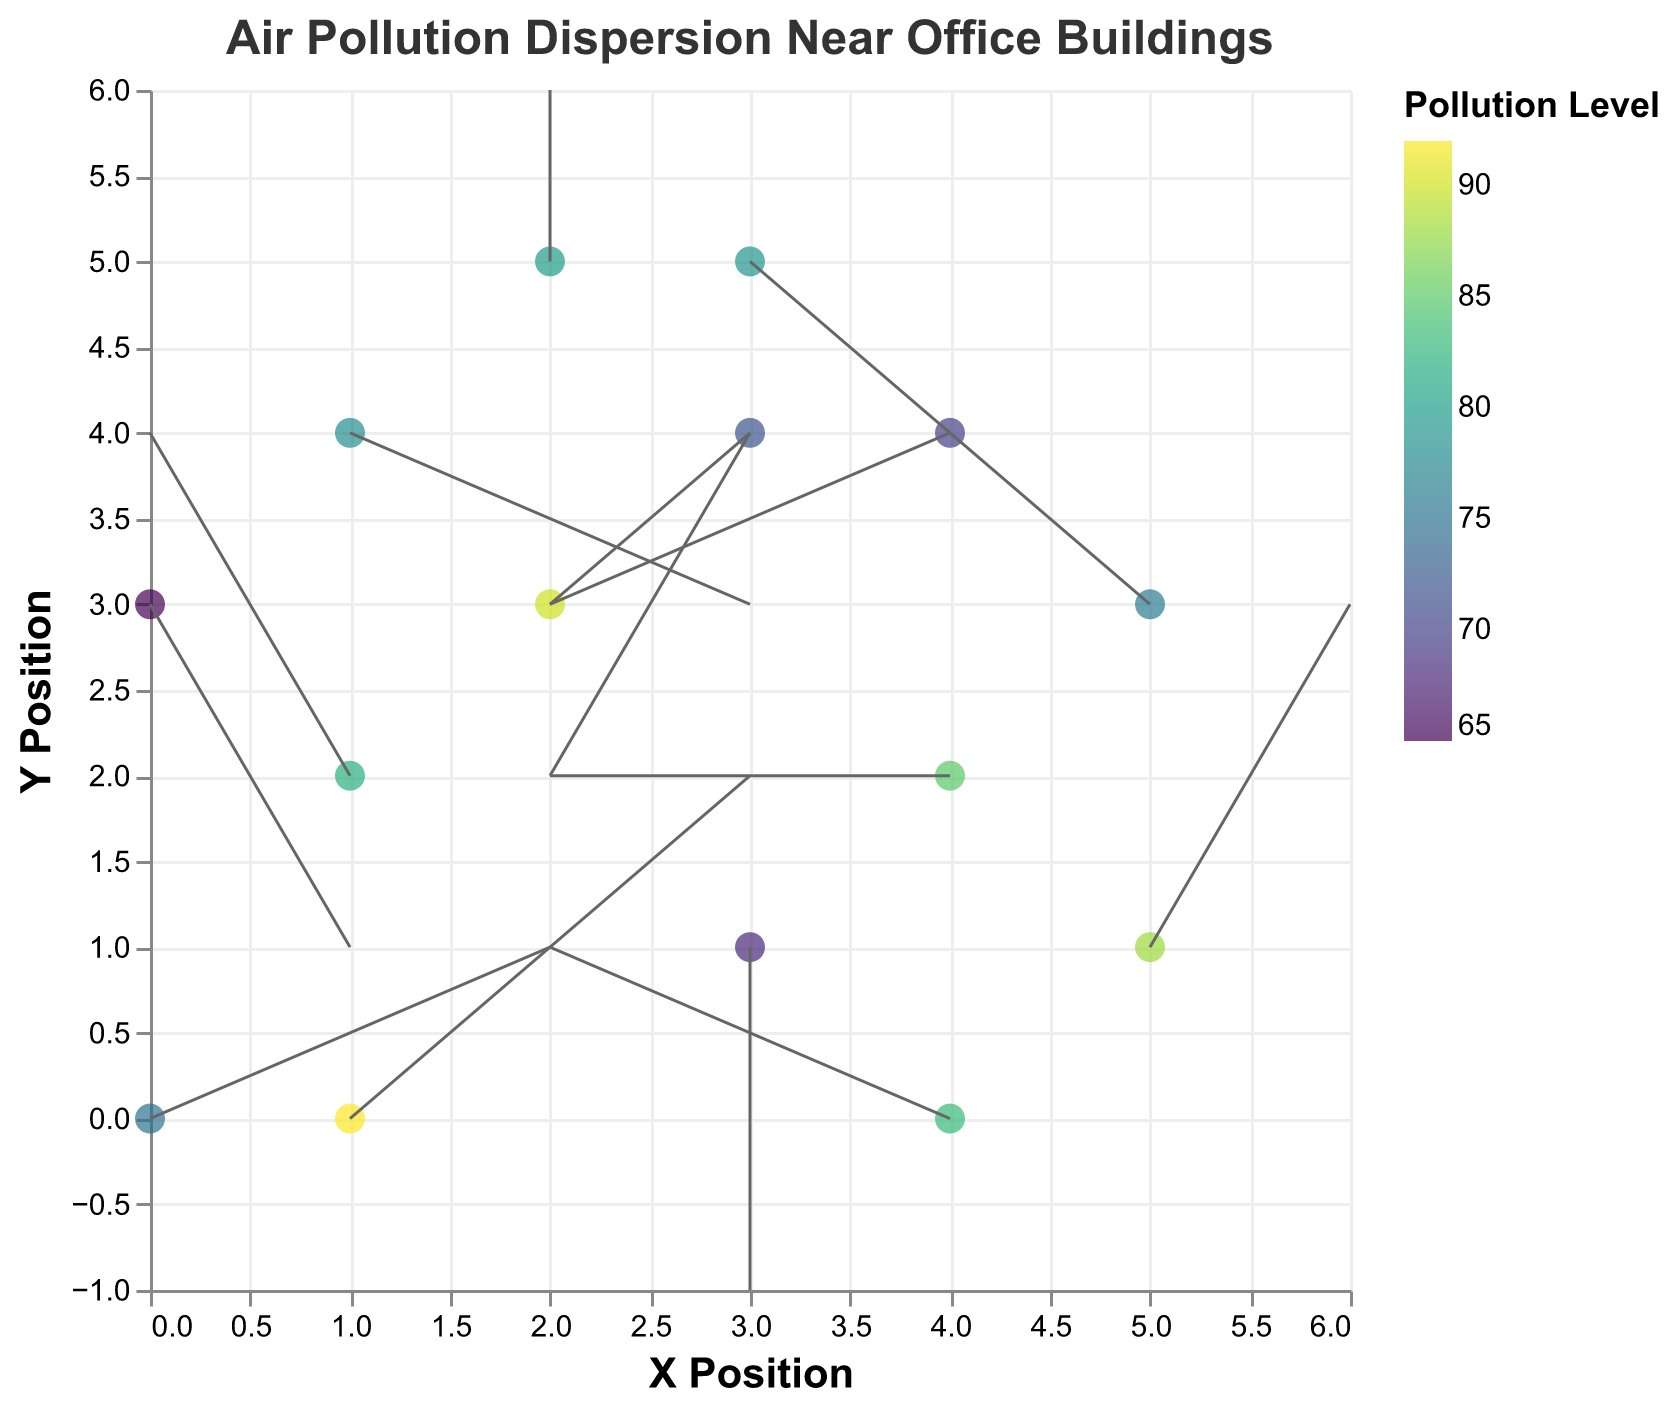How many data points are displayed in the figure? To determine the number of data points, count each distinct (x, y) coordinate pair visible in the figure.
Answer: 15 Which position has the highest pollution level, and what is the pollution level there? Look for the point associated with the highest color intensity and check its tooltip or color legend. The position (1,0) has the highest value with a pollution level of 92.
Answer: (1, 0), 92 Compare the pollution levels at positions (0,0) and (2,3). Which one is higher? Verify the pollution levels at these coordinates by looking at their respective colors or values in the tooltip. The pollution levels are 75 and 90, respectively.
Answer: (2, 3) is higher What is the direction and magnitude of the vector at the origin (0,0)? The vector at (0,0) is directed by the (u, v) components provided, which are (2,1). The direction is right and slightly up, and the magnitude is √(2^2 + 1^2) = √5.
Answer: Right and up, √5 How many vectors have a negative x-component (u)? Count the entries where the vector's x-component (u) is negative: (-1, 2), (-2, 0), (-1, -2), (-2, -1), (-1, 1). There are 5 such vectors.
Answer: 5 What is the average pollution level in the given data points? Sum all pollution levels and divide by the number of points: (75 + 82 + 68 + 90 + 85 + 78 + 72 + 88 + 80 + 70 + 65 + 76 + 92 + 83 + 79) / 15 = 79.27.
Answer: 79.27 Do all vectors point towards higher pollution levels? Observe if vectors' directions correlate with transitioning to higher pollution levels by visual inspection. The answer may vary, but several vectors do not seem to strictly point towards higher pollution areas.
Answer: No Is there any specific area (quadrant) with predominantly high pollution levels? Visually inspect whether any quadrant (top-left, top-right, bottom-left, bottom-right) primarily contains high pollution levels. The top-right quadrant frequently shows high pollution.
Answer: Top-right quadrant Which data point has the highest positive y-component (v) of its vector? The vector with the highest positive y-component can be identified from its value: (1, 2) with a v value of 2 has the maximum positive y-component.
Answer: (1, 2) 